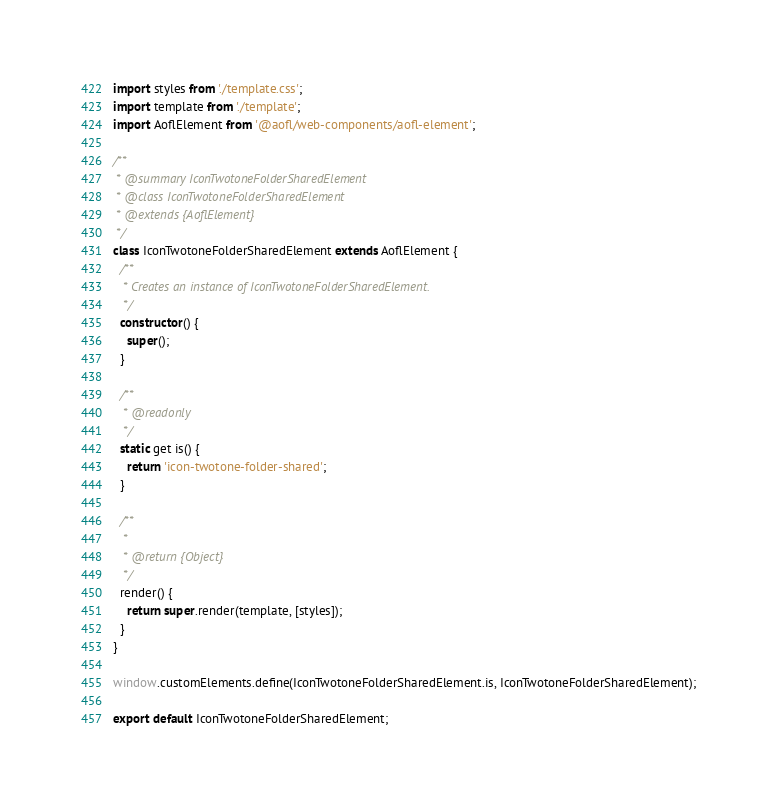Convert code to text. <code><loc_0><loc_0><loc_500><loc_500><_JavaScript_>import styles from './template.css';
import template from './template';
import AoflElement from '@aofl/web-components/aofl-element';

/**
 * @summary IconTwotoneFolderSharedElement
 * @class IconTwotoneFolderSharedElement
 * @extends {AoflElement}
 */
class IconTwotoneFolderSharedElement extends AoflElement {
  /**
   * Creates an instance of IconTwotoneFolderSharedElement.
   */
  constructor() {
    super();
  }

  /**
   * @readonly
   */
  static get is() {
    return 'icon-twotone-folder-shared';
  }

  /**
   *
   * @return {Object}
   */
  render() {
    return super.render(template, [styles]);
  }
}

window.customElements.define(IconTwotoneFolderSharedElement.is, IconTwotoneFolderSharedElement);

export default IconTwotoneFolderSharedElement;
</code> 